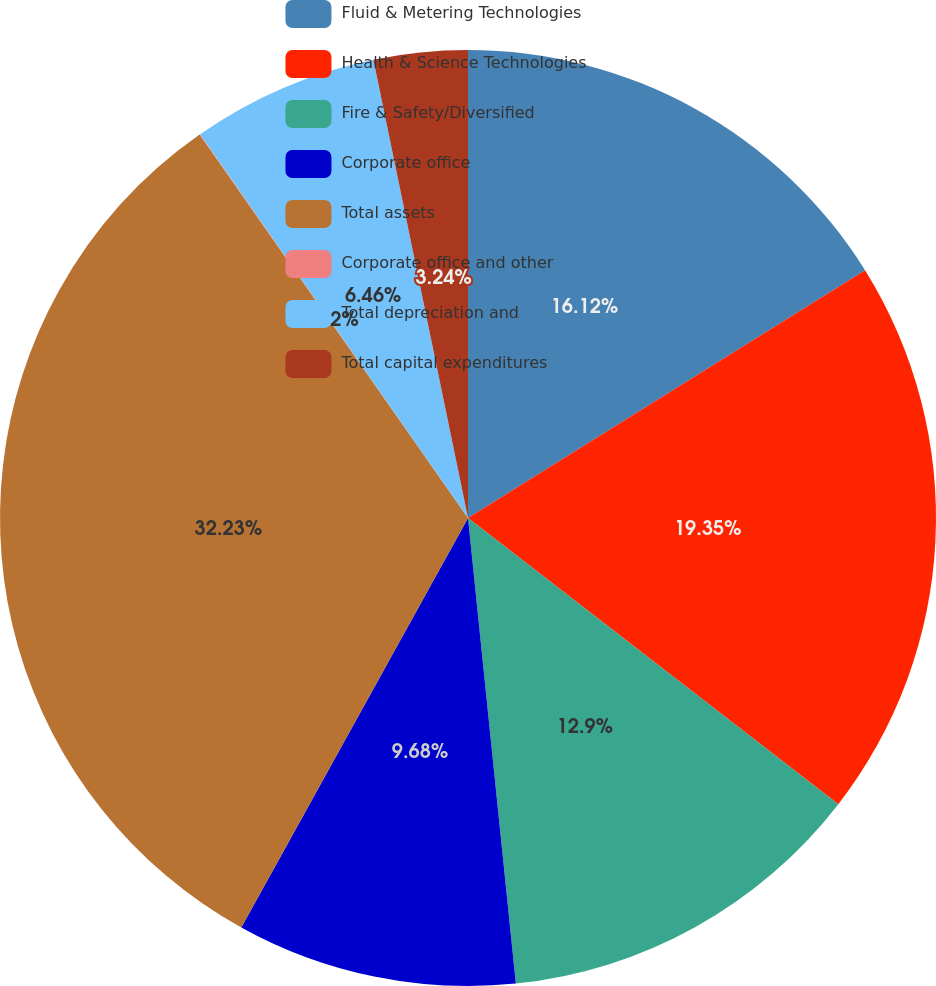Convert chart to OTSL. <chart><loc_0><loc_0><loc_500><loc_500><pie_chart><fcel>Fluid & Metering Technologies<fcel>Health & Science Technologies<fcel>Fire & Safety/Diversified<fcel>Corporate office<fcel>Total assets<fcel>Corporate office and other<fcel>Total depreciation and<fcel>Total capital expenditures<nl><fcel>16.12%<fcel>19.35%<fcel>12.9%<fcel>9.68%<fcel>32.23%<fcel>0.02%<fcel>6.46%<fcel>3.24%<nl></chart> 